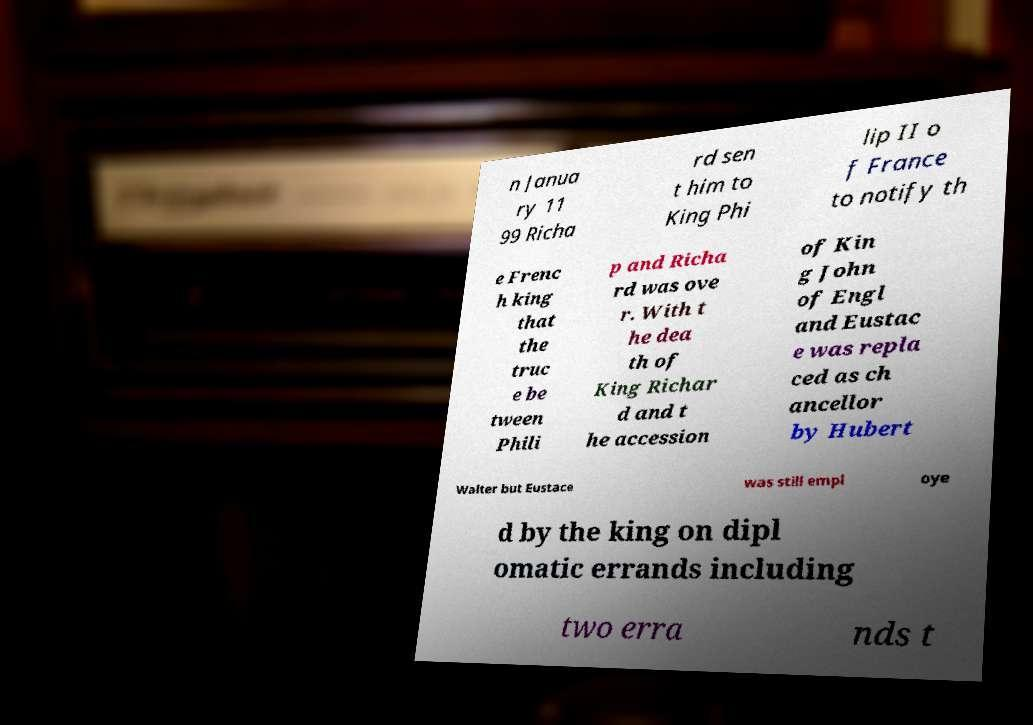Please read and relay the text visible in this image. What does it say? n Janua ry 11 99 Richa rd sen t him to King Phi lip II o f France to notify th e Frenc h king that the truc e be tween Phili p and Richa rd was ove r. With t he dea th of King Richar d and t he accession of Kin g John of Engl and Eustac e was repla ced as ch ancellor by Hubert Walter but Eustace was still empl oye d by the king on dipl omatic errands including two erra nds t 